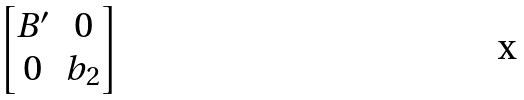Convert formula to latex. <formula><loc_0><loc_0><loc_500><loc_500>\begin{bmatrix} B ^ { \prime } & 0 \\ 0 & b _ { 2 } \end{bmatrix}</formula> 